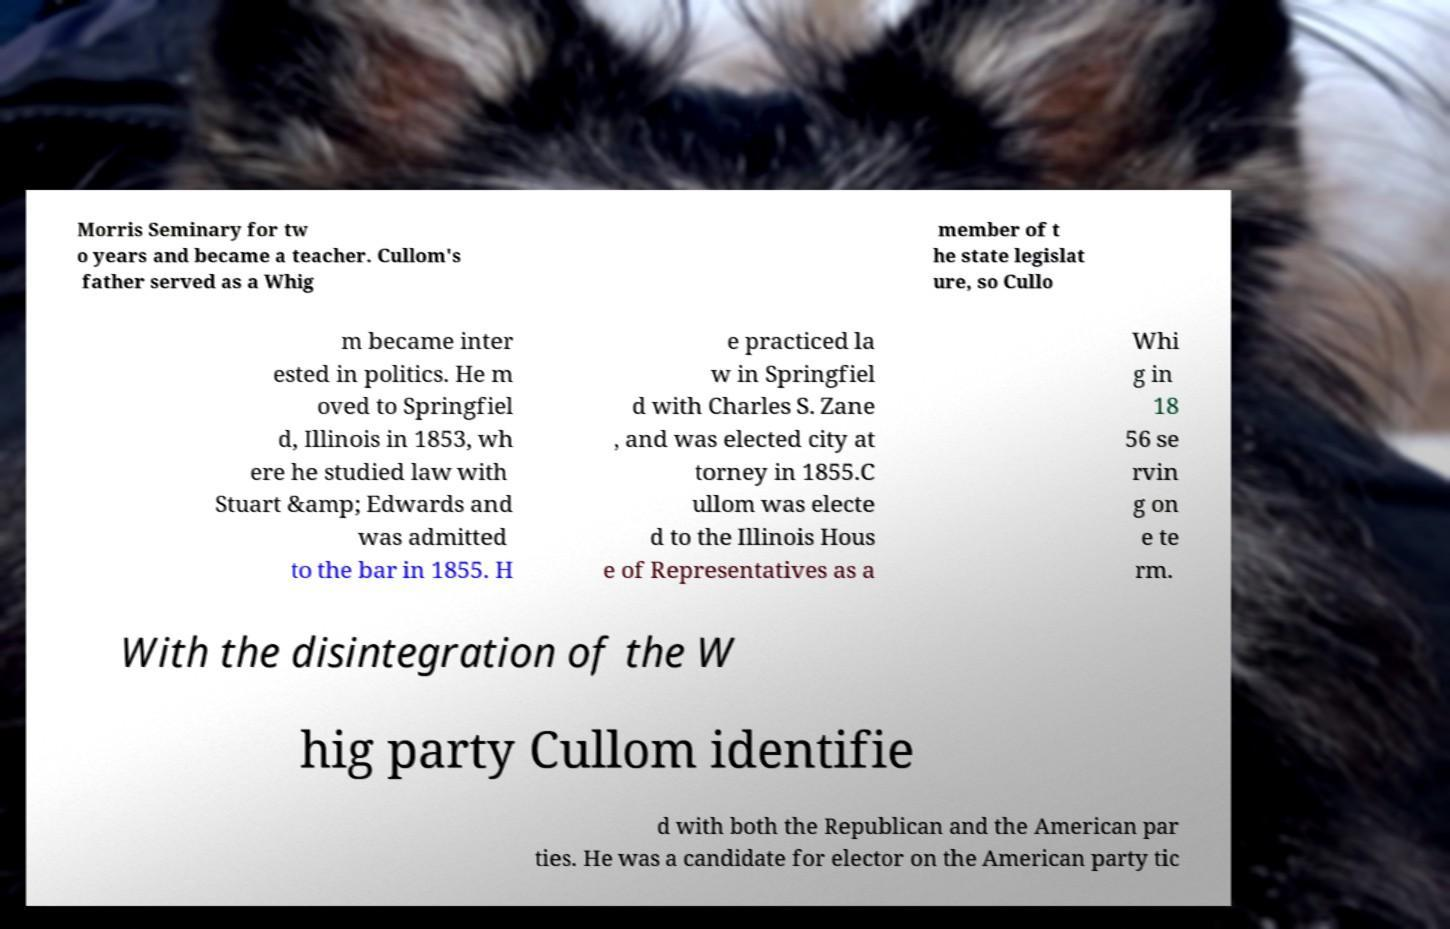Could you assist in decoding the text presented in this image and type it out clearly? Morris Seminary for tw o years and became a teacher. Cullom's father served as a Whig member of t he state legislat ure, so Cullo m became inter ested in politics. He m oved to Springfiel d, Illinois in 1853, wh ere he studied law with Stuart &amp; Edwards and was admitted to the bar in 1855. H e practiced la w in Springfiel d with Charles S. Zane , and was elected city at torney in 1855.C ullom was electe d to the Illinois Hous e of Representatives as a Whi g in 18 56 se rvin g on e te rm. With the disintegration of the W hig party Cullom identifie d with both the Republican and the American par ties. He was a candidate for elector on the American party tic 